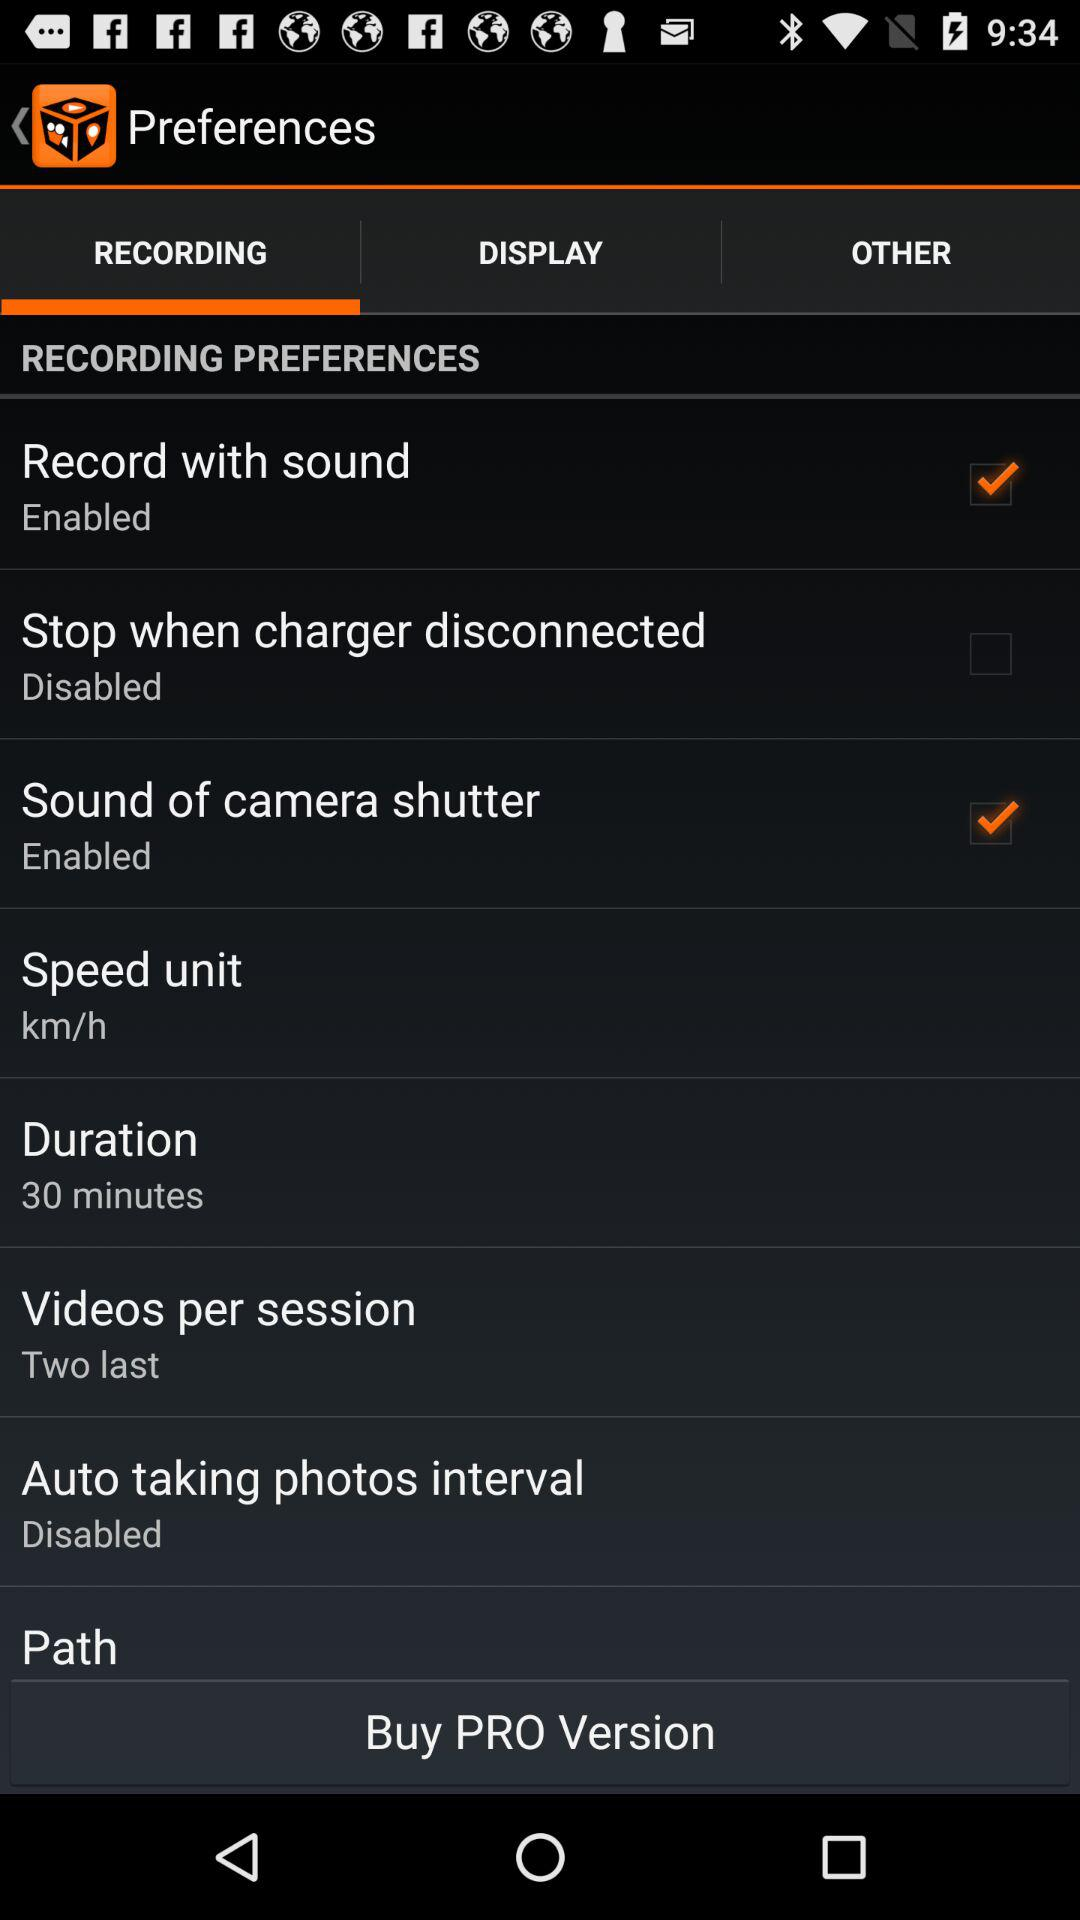What is the status of "Record with sound"? The status of "Record with sound" is "on". 